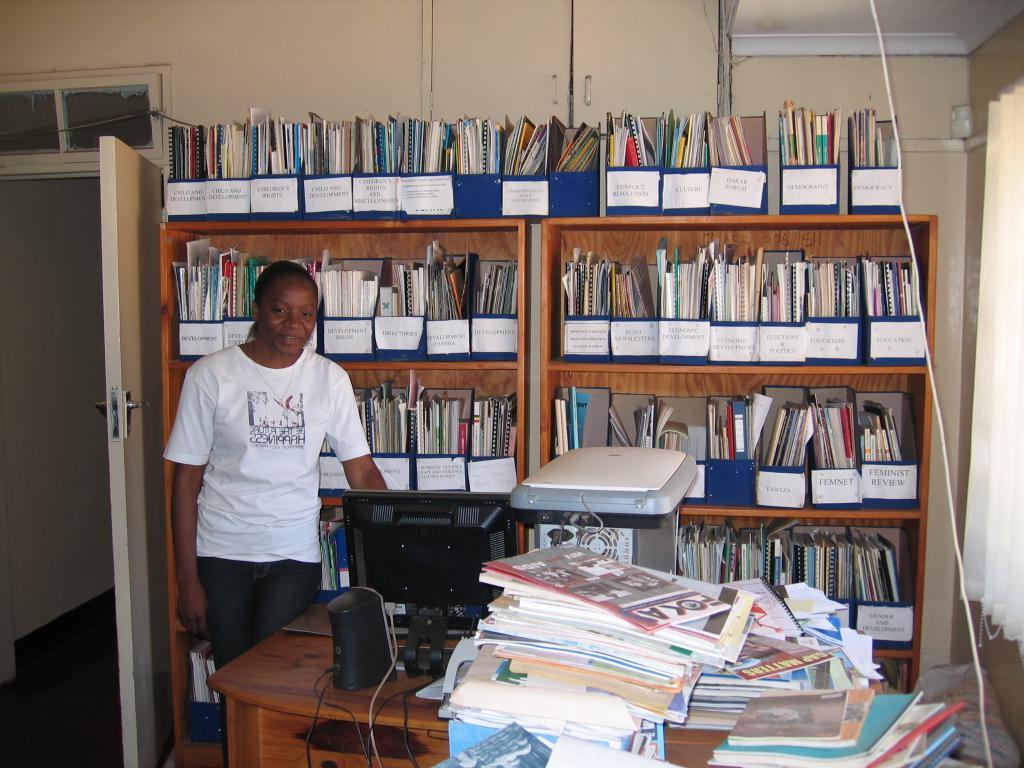What kind of review is seen on the right side?
Your answer should be very brief. Feminist. Does her shirt say "happiness" on it?
Provide a succinct answer. Yes. 